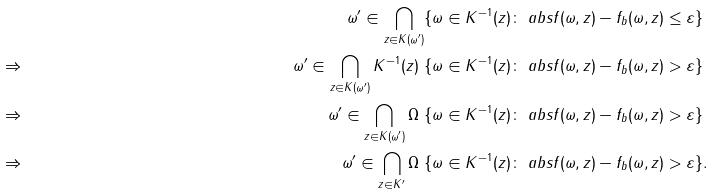Convert formula to latex. <formula><loc_0><loc_0><loc_500><loc_500>& & \omega ^ { \prime } \in \bigcap _ { z \in K ( \omega ^ { \prime } ) } \{ \omega \in K ^ { - 1 } ( z ) \colon \ a b s { f ( \omega , z ) - f _ { b } ( \omega , z ) } \leq \varepsilon \} & & \\ & \Rightarrow & \omega ^ { \prime } \in \bigcap _ { z \in K ( \omega ^ { \prime } ) } K ^ { - 1 } ( z ) \ \{ \omega \in K ^ { - 1 } ( z ) \colon \ a b s { f ( \omega , z ) - f _ { b } ( \omega , z ) } > \varepsilon \} & \\ & \Rightarrow & \omega ^ { \prime } \in \bigcap _ { z \in K ( \omega ^ { \prime } ) } \Omega \ \{ \omega \in K ^ { - 1 } ( z ) \colon \ a b s { f ( \omega , z ) - f _ { b } ( \omega , z ) } > \varepsilon \} & \\ & \Rightarrow & \omega ^ { \prime } \in \bigcap _ { z \in K ^ { \prime } } \Omega \ \{ \omega \in K ^ { - 1 } ( z ) \colon \ a b s { f ( \omega , z ) - f _ { b } ( \omega , z ) } > \varepsilon \} & .</formula> 